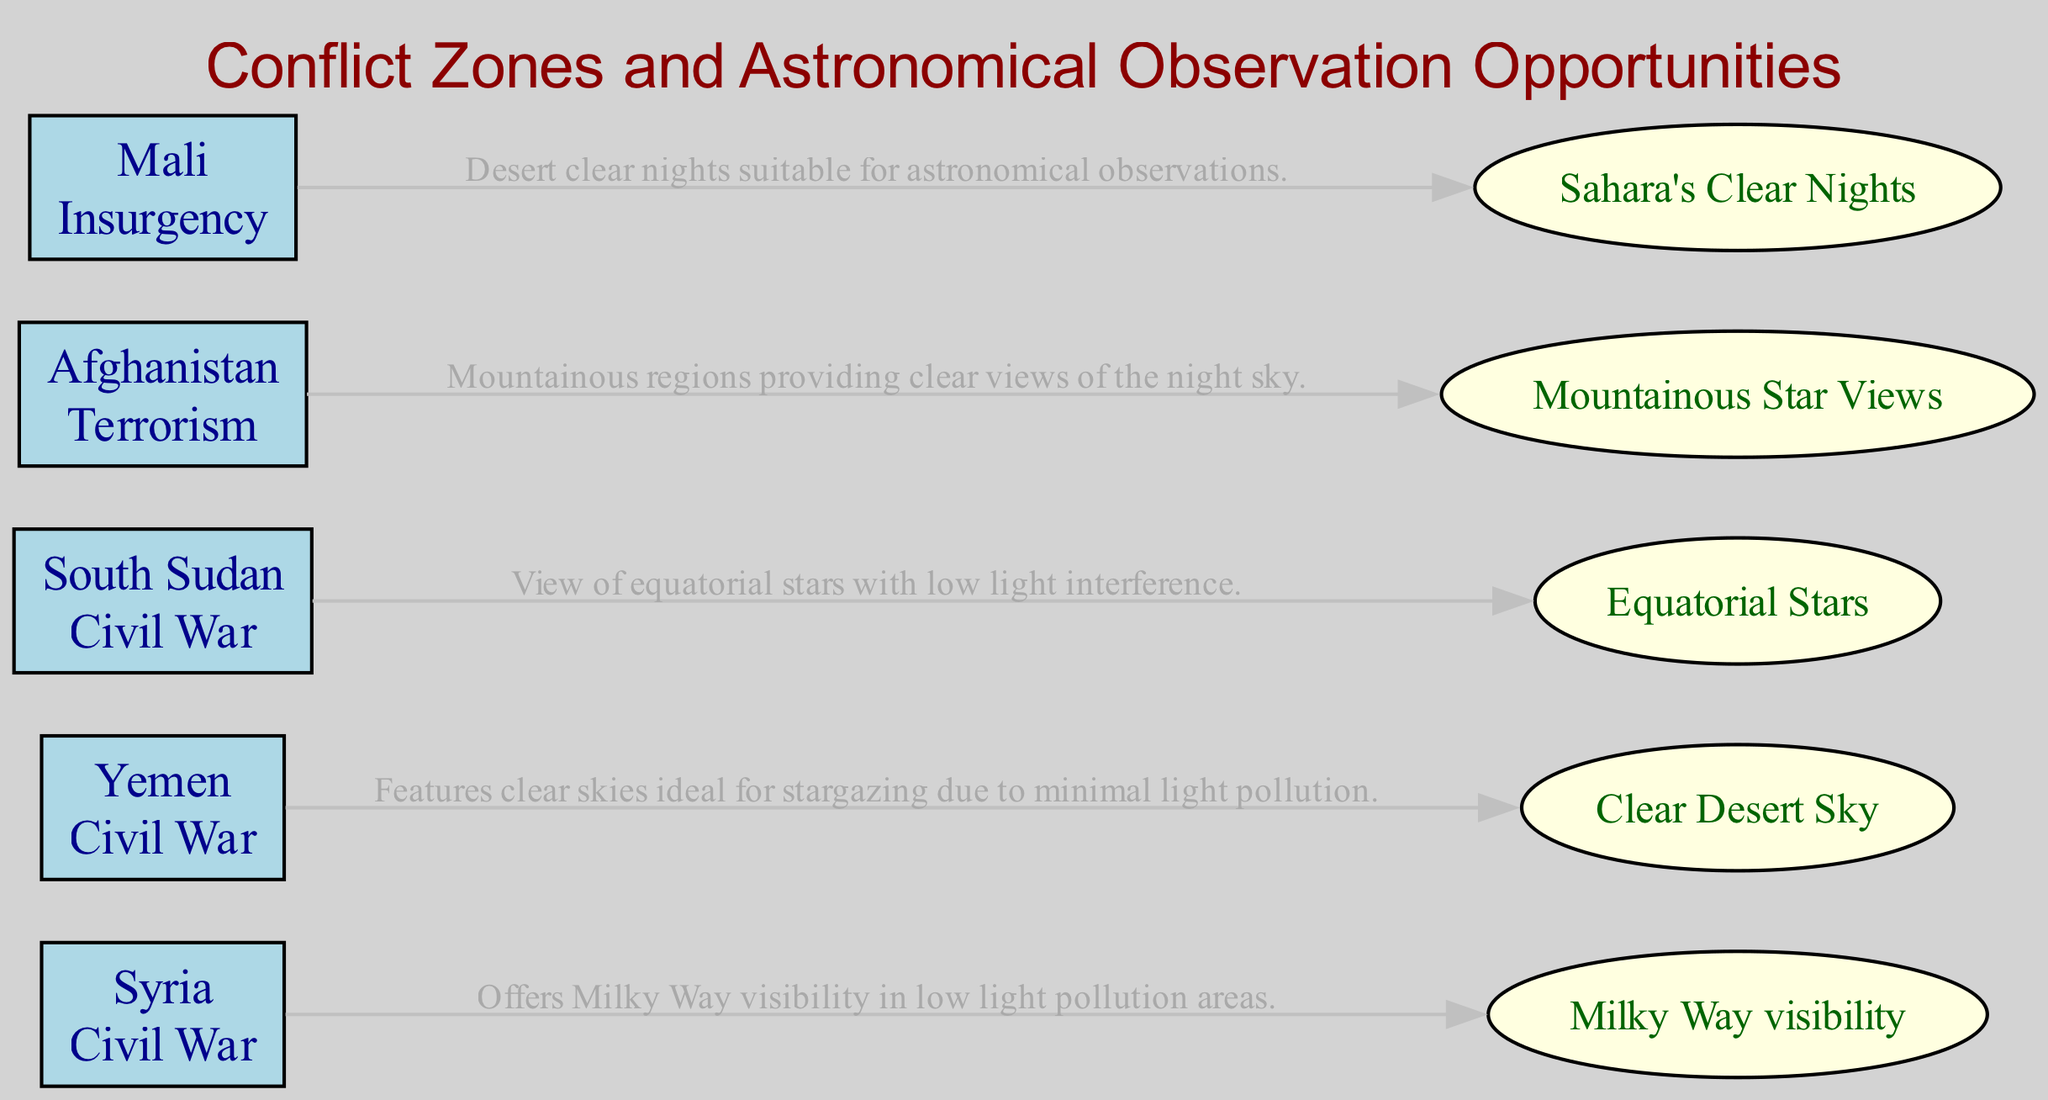What is the conflict type in Syria? The diagram indicates that Syria is categorized as a conflict zone with the specific conflict type being "Civil War." This information comes directly from the attributes listed for Syria within the nodes.
Answer: Civil War How many conflict zones are identified in the diagram? The diagram contains a total of five nodes, each representing a different conflict zone (Syria, Yemen, South Sudan, Afghanistan, and Mali). Therefore, the count of conflict zones is derived from the number of nodes in the data.
Answer: 5 Which region offers visibility of the Milky Way? According to the edge connecting Syria to the unique sky view, the diagram states that Syria offers "Milky Way visibility" as one of its attributes. Thus, this is directly derived from the information associated with Syria.
Answer: Syria What is the light pollution level in Yemen? The attributes for Yemen in the diagram specify that its light pollution level is "Minimal." This information is easily identifiable from the attributes specified for the Yemen node.
Answer: Minimal What unique sky view does Afghanistan provide? The description in the Afghanistan node indicates that it provides "Mountainous Star Views," which is listed as its unique sky view. This directly answers the question about what unique view Afghanistan offers.
Answer: Mountainous Star Views Which conflict zone features clear skies ideal for stargazing? Yemen is described in the diagram as having minimal light pollution, which allows for clear skies that are especially suitable for stargazing. This conclusion is drawn from the attributes linked to Yemen.
Answer: Yemen Which conflict zone has low light pollution and offers views of equatorial stars? South Sudan is specified in the diagram as having a low light pollution level and offers a view of "Equatorial Stars," making it the answer to the question. This information is directly available from the attributes of South Sudan.
Answer: South Sudan In which region can you observe the Sahara's clear nights? The diagram indicates that Mali is associated with "Sahara's Clear Nights" as its unique sky view. This information is explicitly mentioned in the attributes for Mali, providing the answer.
Answer: Mali Which region has a conflict type classified as insurgency? The diagram lists Mali's conflict type as "Insurgency" when detailing its attributes, thus providing the specific answer to the query about the conflict classification.
Answer: Insurgency 